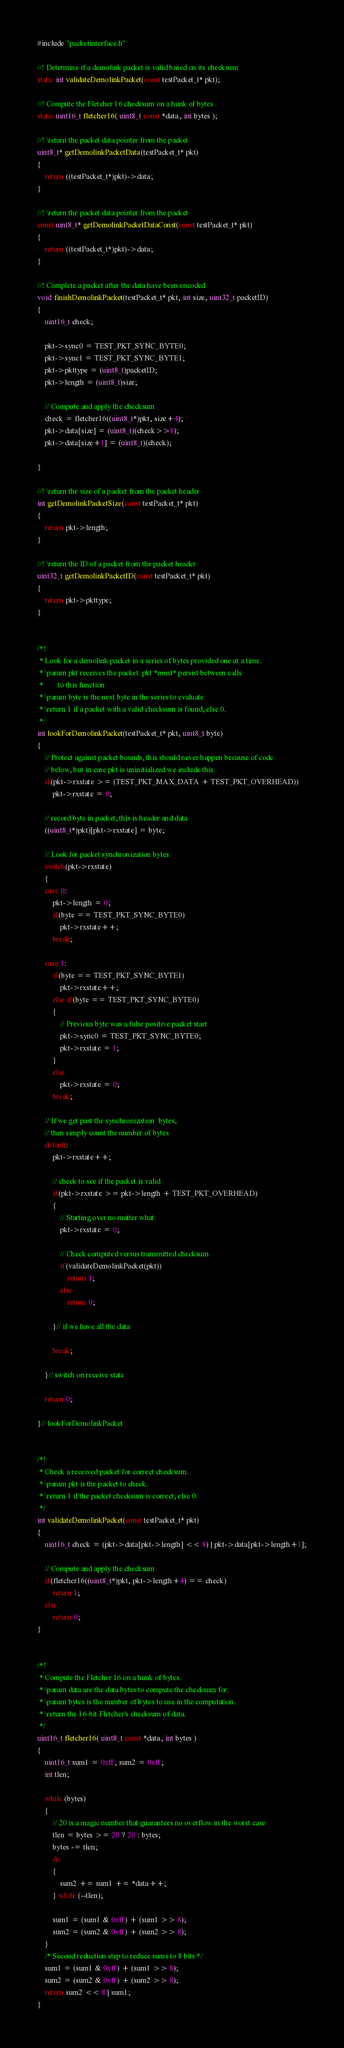Convert code to text. <code><loc_0><loc_0><loc_500><loc_500><_C_>#include "packetinterface.h"

//! Determine if a demolink packet is valid based on its checksum
static int validateDemolinkPacket(const testPacket_t* pkt);

//! Compute the Fletcher 16 checksum on a hunk of bytes
static uint16_t fletcher16( uint8_t const *data, int bytes );

//! \return the packet data pointer from the packet
uint8_t* getDemolinkPacketData(testPacket_t* pkt)
{
    return ((testPacket_t*)pkt)->data;
}

//! \return the packet data pointer from the packet
const uint8_t* getDemolinkPacketDataConst(const testPacket_t* pkt)
{
    return ((testPacket_t*)pkt)->data;
}

//! Complete a packet after the data have been encoded
void finishDemolinkPacket(testPacket_t* pkt, int size, uint32_t packetID)
{
    uint16_t check;

    pkt->sync0 = TEST_PKT_SYNC_BYTE0;
    pkt->sync1 = TEST_PKT_SYNC_BYTE1;
    pkt->pkttype = (uint8_t)packetID;
    pkt->length = (uint8_t)size;

    // Compute and apply the checksum
    check = fletcher16((uint8_t*)pkt, size+4);
    pkt->data[size] = (uint8_t)(check>>8);
    pkt->data[size+1] = (uint8_t)(check);

}

//! \return the size of a packet from the packet header
int getDemolinkPacketSize(const testPacket_t* pkt)
{
    return pkt->length;
}

//! \return the ID of a packet from the packet header
uint32_t getDemolinkPacketID(const testPacket_t* pkt)
{
    return pkt->pkttype;
}


/*!
 * Look for a demolink packet in a series of bytes provided one at a time.
 * \param pkt receives the packet. pkt *must* persist between calls
 *        to this function
 * \param byte is the next byte in the series to evaluate
 * \return 1 if a packet with a valid checksum is found, else 0.
 */
int lookForDemolinkPacket(testPacket_t* pkt, uint8_t byte)
{
    // Protect against packet bounds, this should never happen because of code
    // below, but in case pkt is uninitialized we include this.
    if(pkt->rxstate >= (TEST_PKT_MAX_DATA + TEST_PKT_OVERHEAD))
        pkt->rxstate = 0;

    // record byte in packet, this is header and data
    ((uint8_t*)pkt)[pkt->rxstate] = byte;

    // Look for packet synchronization bytes
    switch(pkt->rxstate)
    {
    case 0:
        pkt->length = 0;
        if(byte == TEST_PKT_SYNC_BYTE0)
            pkt->rxstate++;
        break;

    case 1:
        if(byte == TEST_PKT_SYNC_BYTE1)
            pkt->rxstate++;
        else if(byte == TEST_PKT_SYNC_BYTE0)
        {
            // Previous byte was a false positive packet start
            pkt->sync0 = TEST_PKT_SYNC_BYTE0;
            pkt->rxstate = 1;
        }
        else
            pkt->rxstate = 0;
        break;

    // If we get past the synchronization  bytes,
    // then simply count the number of bytes
    default:
        pkt->rxstate++;

        // check to see if the packet is valid
        if(pkt->rxstate >= pkt->length + TEST_PKT_OVERHEAD)
        {
            // Starting over no matter what
            pkt->rxstate = 0;

            // Check computed versus transmitted checksum
            if(validateDemolinkPacket(pkt))
                return 1;
            else
                return 0;

        }// if we have all the data

        break;

    }// switch on receive state

    return 0;

}// lookForDemolinkPacket


/*!
 * Check a received packet for correct checksum.
 * \param pkt is the packet to check.
 * \return 1 if the packet checksum is correct, else 0.
 */
int validateDemolinkPacket(const testPacket_t* pkt)
{
    uint16_t check = (pkt->data[pkt->length] << 8) | pkt->data[pkt->length+1];

    // Compute and apply the checksum
    if(fletcher16((uint8_t*)pkt, pkt->length+4) == check)
        return 1;
    else
        return 0;
}


/*!
 * Compute the Fletcher 16 on a hunk of bytes.
 * \param data are the data bytes to compute the checksum for.
 * \param bytes is the number of bytes to use in the computation.
 * \return the 16-bit Fletcher's checksum of data.
 */
uint16_t fletcher16( uint8_t const *data, int bytes )
{
    uint16_t sum1 = 0xff, sum2 = 0xff;
    int tlen;

    while (bytes)
    {
        // 20 is a magic number that guarantees no overflow in the worst case
        tlen = bytes >= 20 ? 20 : bytes;
        bytes -= tlen;
        do
        {
            sum2 += sum1 += *data++;
        } while (--tlen);

        sum1 = (sum1 & 0xff) + (sum1 >> 8);
        sum2 = (sum2 & 0xff) + (sum2 >> 8);
    }
    /* Second reduction step to reduce sums to 8 bits */
    sum1 = (sum1 & 0xff) + (sum1 >> 8);
    sum2 = (sum2 & 0xff) + (sum2 >> 8);
    return sum2 << 8 | sum1;
}
</code> 